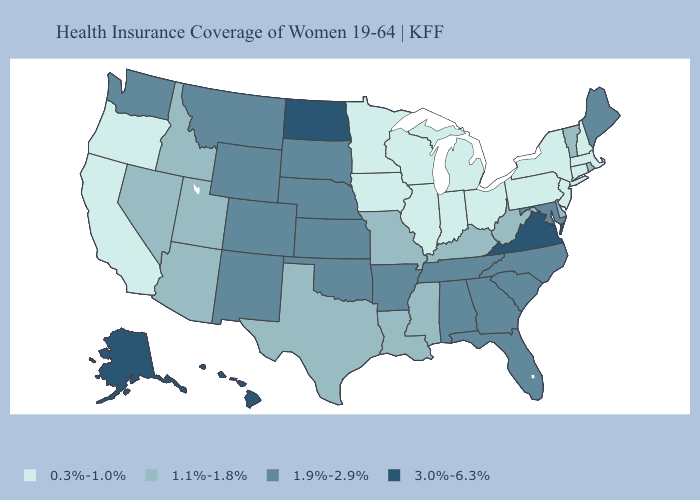Among the states that border Illinois , which have the lowest value?
Quick response, please. Indiana, Iowa, Wisconsin. What is the lowest value in the Northeast?
Quick response, please. 0.3%-1.0%. Does Connecticut have a lower value than Montana?
Keep it brief. Yes. Name the states that have a value in the range 1.9%-2.9%?
Quick response, please. Alabama, Arkansas, Colorado, Florida, Georgia, Kansas, Maine, Maryland, Montana, Nebraska, New Mexico, North Carolina, Oklahoma, South Carolina, South Dakota, Tennessee, Washington, Wyoming. What is the highest value in states that border Utah?
Concise answer only. 1.9%-2.9%. Is the legend a continuous bar?
Concise answer only. No. Name the states that have a value in the range 3.0%-6.3%?
Give a very brief answer. Alaska, Hawaii, North Dakota, Virginia. What is the value of Connecticut?
Write a very short answer. 0.3%-1.0%. Name the states that have a value in the range 3.0%-6.3%?
Short answer required. Alaska, Hawaii, North Dakota, Virginia. Name the states that have a value in the range 3.0%-6.3%?
Concise answer only. Alaska, Hawaii, North Dakota, Virginia. Name the states that have a value in the range 1.9%-2.9%?
Be succinct. Alabama, Arkansas, Colorado, Florida, Georgia, Kansas, Maine, Maryland, Montana, Nebraska, New Mexico, North Carolina, Oklahoma, South Carolina, South Dakota, Tennessee, Washington, Wyoming. Does Kansas have the lowest value in the MidWest?
Quick response, please. No. What is the value of Louisiana?
Write a very short answer. 1.1%-1.8%. Name the states that have a value in the range 1.1%-1.8%?
Concise answer only. Arizona, Delaware, Idaho, Kentucky, Louisiana, Mississippi, Missouri, Nevada, Rhode Island, Texas, Utah, Vermont, West Virginia. Name the states that have a value in the range 1.1%-1.8%?
Concise answer only. Arizona, Delaware, Idaho, Kentucky, Louisiana, Mississippi, Missouri, Nevada, Rhode Island, Texas, Utah, Vermont, West Virginia. 